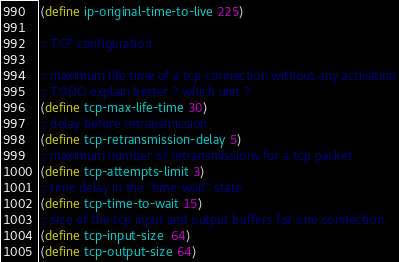Convert code to text. <code><loc_0><loc_0><loc_500><loc_500><_Scheme_>

(define ip-original-time-to-live 225)

;; TCP configuration

;; maximum life time of a tcp connection without any activation
;; TODO explain better ? which unit ?
(define tcp-max-life-time 30)
;; delay before retransmission
(define tcp-retransmission-delay 5)
;; maximum number of retransmissions for a tcp packet
(define tcp-attempts-limit 3)
;; time delay in the "time-wait" state
(define tcp-time-to-wait 15)
;; size of the tcp input and output buffers for one connection.
(define tcp-input-size  64)
(define tcp-output-size 64)
</code> 